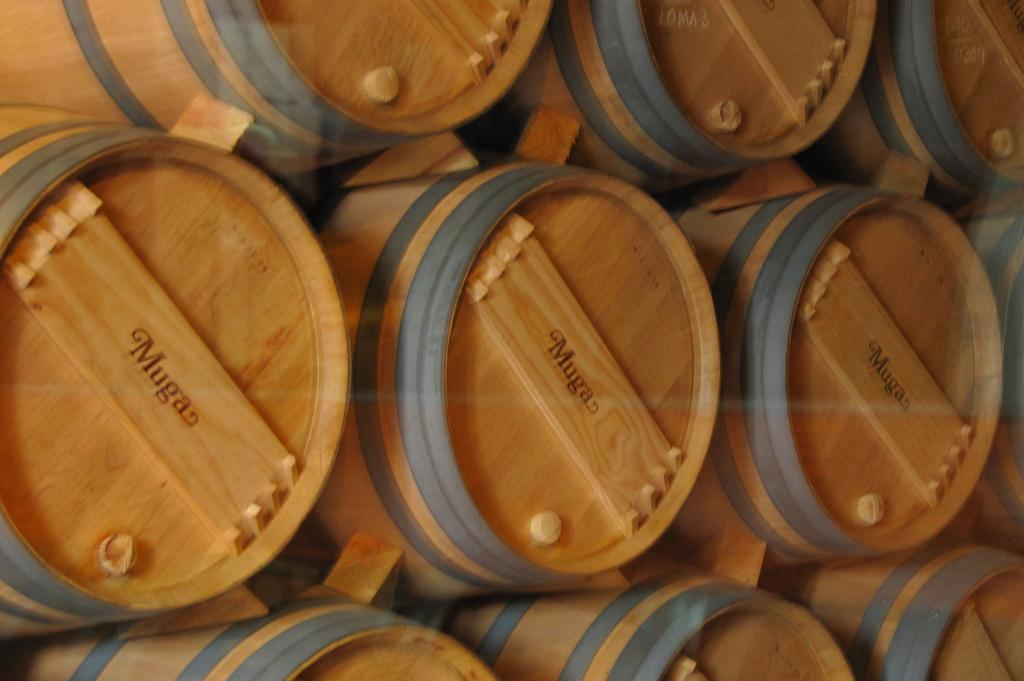What type of objects can be seen in the image? There are barrels in the image. What else is present on the wooden planks in the image? There are names on the wooden planks in the image. What type of vest can be seen in the image? There is no vest present in the image; it only features barrels and names on wooden planks. 